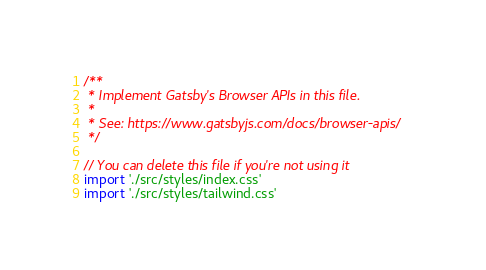<code> <loc_0><loc_0><loc_500><loc_500><_JavaScript_>/**
 * Implement Gatsby's Browser APIs in this file.
 *
 * See: https://www.gatsbyjs.com/docs/browser-apis/
 */

// You can delete this file if you're not using it
import './src/styles/index.css'
import './src/styles/tailwind.css'
</code> 